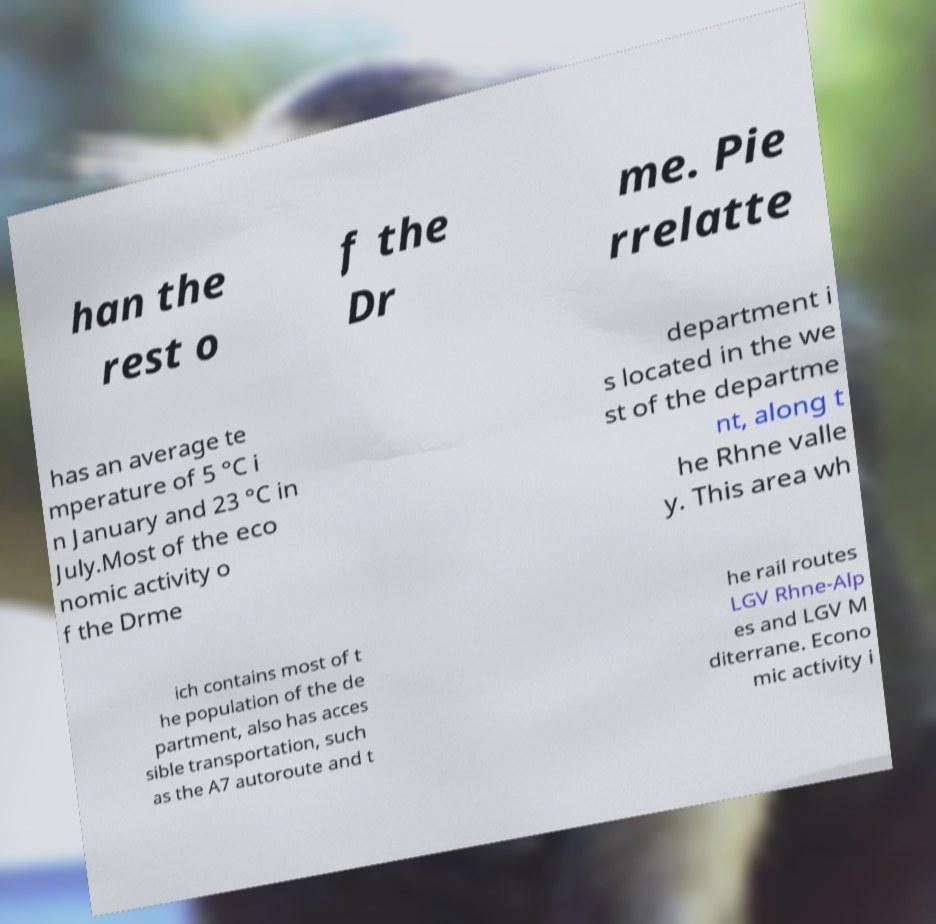What messages or text are displayed in this image? I need them in a readable, typed format. han the rest o f the Dr me. Pie rrelatte has an average te mperature of 5 °C i n January and 23 °C in July.Most of the eco nomic activity o f the Drme department i s located in the we st of the departme nt, along t he Rhne valle y. This area wh ich contains most of t he population of the de partment, also has acces sible transportation, such as the A7 autoroute and t he rail routes LGV Rhne-Alp es and LGV M diterrane. Econo mic activity i 